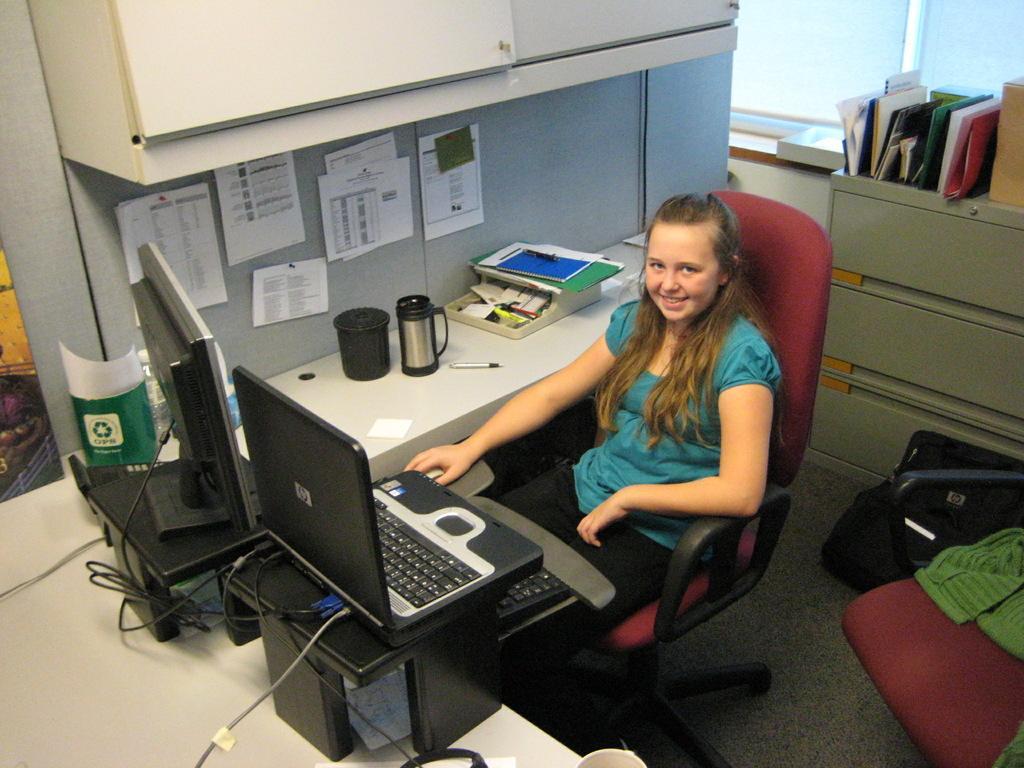Could you give a brief overview of what you see in this image? This picture shows a girl seated on the chair and we see a laptop and a computer and a box on the table and we see few books and a backpack 